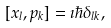<formula> <loc_0><loc_0><loc_500><loc_500>[ x _ { l } , p _ { k } ] = \imath \hbar { \delta } _ { l k } ,</formula> 